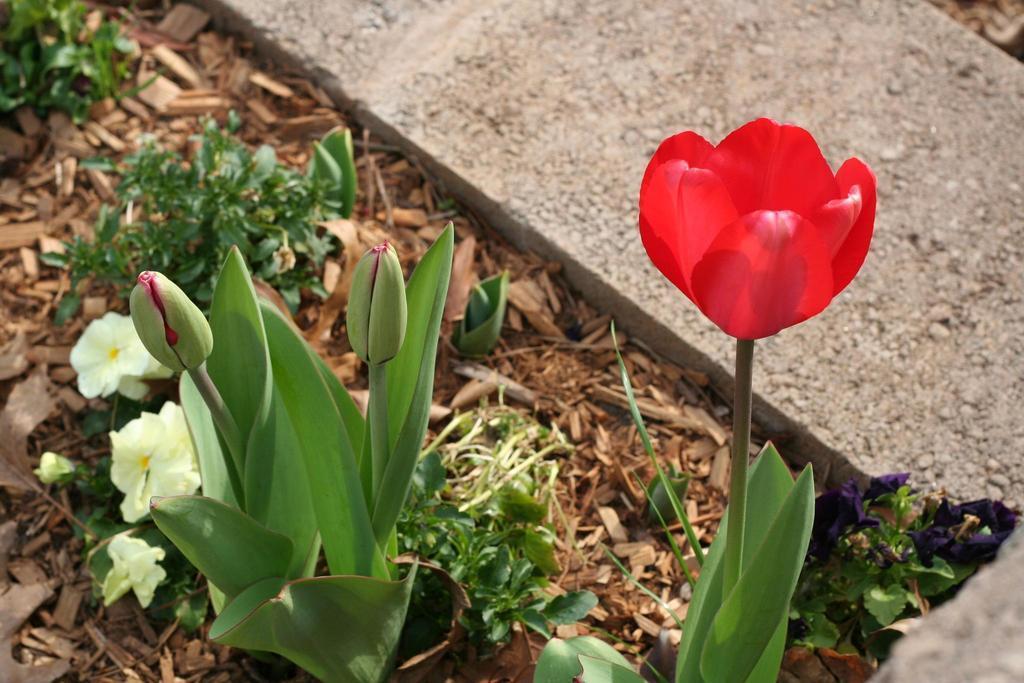Can you describe this image briefly? In the image in the center we can see plants,dry leaves,stone and few flowers,which are in light yellow and red color. 